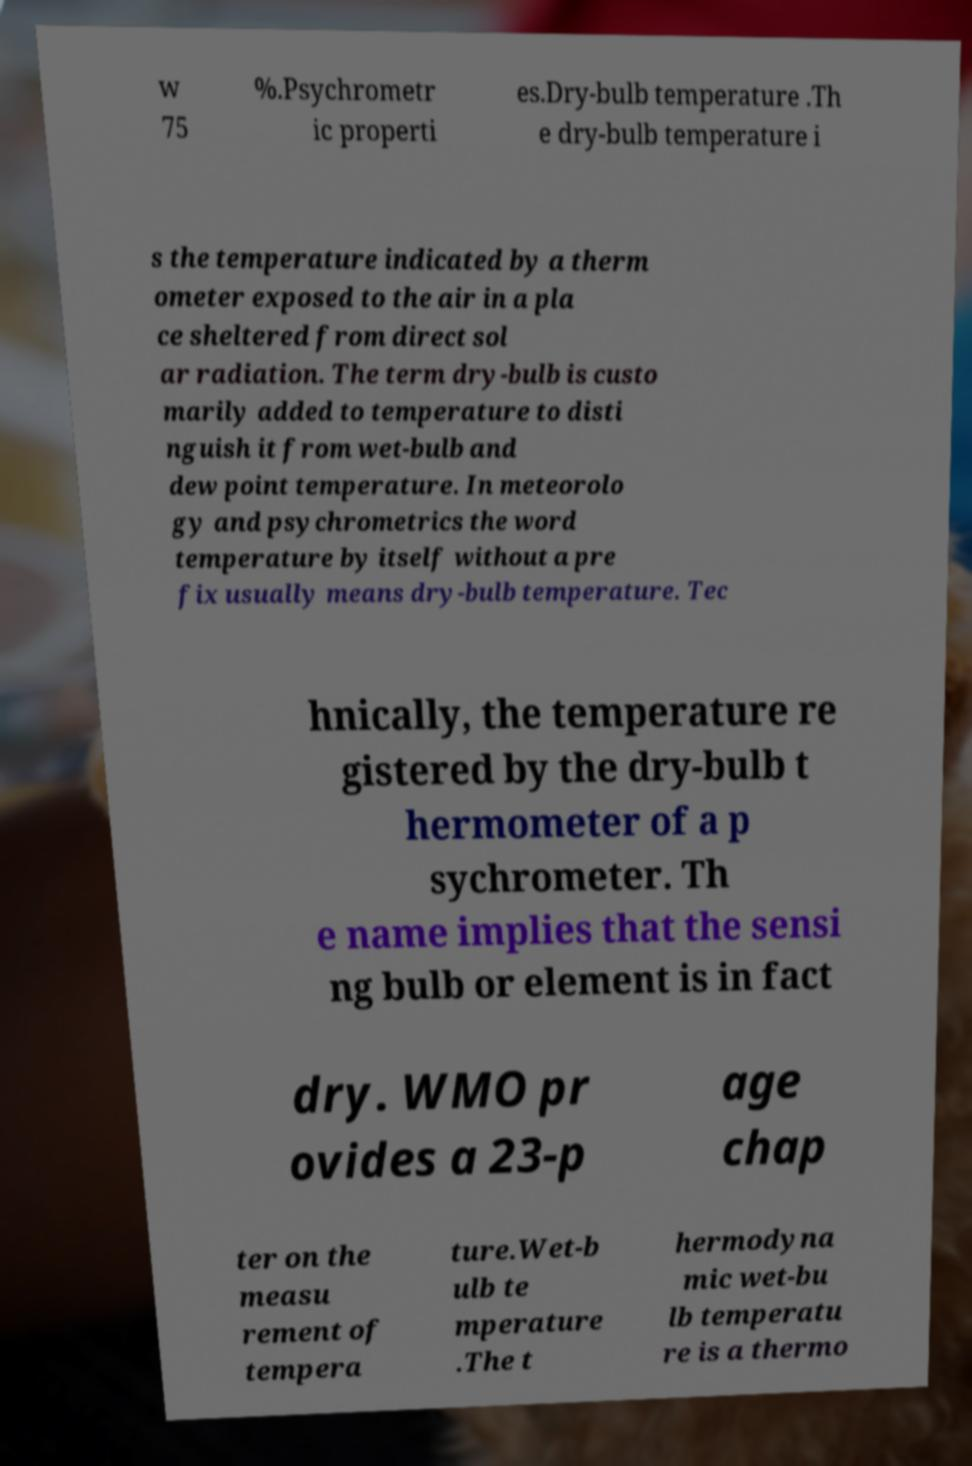Can you accurately transcribe the text from the provided image for me? w 75 %.Psychrometr ic properti es.Dry-bulb temperature .Th e dry-bulb temperature i s the temperature indicated by a therm ometer exposed to the air in a pla ce sheltered from direct sol ar radiation. The term dry-bulb is custo marily added to temperature to disti nguish it from wet-bulb and dew point temperature. In meteorolo gy and psychrometrics the word temperature by itself without a pre fix usually means dry-bulb temperature. Tec hnically, the temperature re gistered by the dry-bulb t hermometer of a p sychrometer. Th e name implies that the sensi ng bulb or element is in fact dry. WMO pr ovides a 23-p age chap ter on the measu rement of tempera ture.Wet-b ulb te mperature .The t hermodyna mic wet-bu lb temperatu re is a thermo 